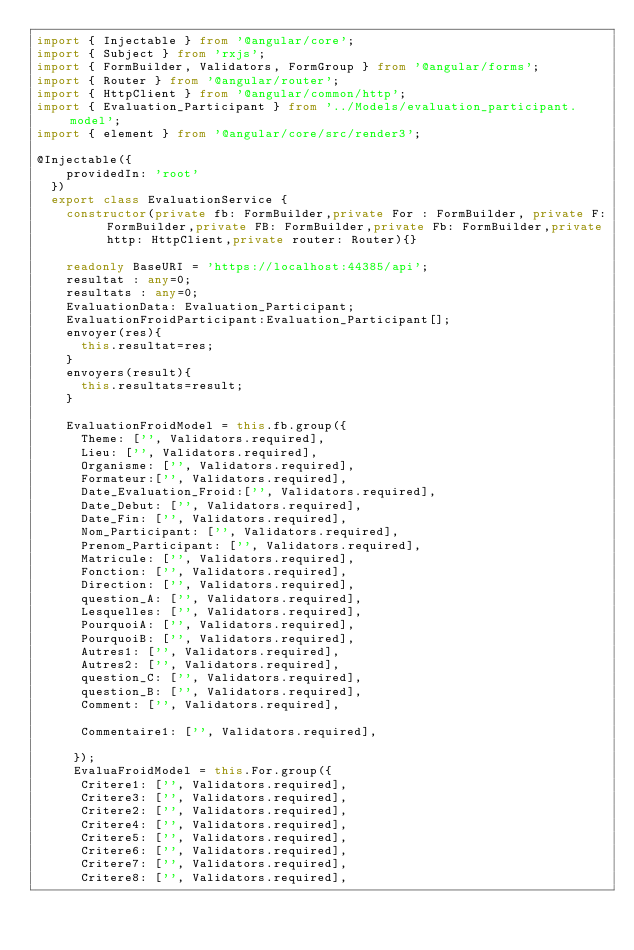Convert code to text. <code><loc_0><loc_0><loc_500><loc_500><_TypeScript_>import { Injectable } from '@angular/core';
import { Subject } from 'rxjs';
import { FormBuilder, Validators, FormGroup } from '@angular/forms';
import { Router } from '@angular/router';
import { HttpClient } from '@angular/common/http';
import { Evaluation_Participant } from '../Models/evaluation_participant.model';
import { element } from '@angular/core/src/render3';

@Injectable({
    providedIn: 'root'
  })
  export class EvaluationService {
    constructor(private fb: FormBuilder,private For : FormBuilder, private F: FormBuilder,private FB: FormBuilder,private Fb: FormBuilder,private http: HttpClient,private router: Router){}

    readonly BaseURI = 'https://localhost:44385/api';
    resultat : any=0;
    resultats : any=0;
    EvaluationData: Evaluation_Participant;
    EvaluationFroidParticipant:Evaluation_Participant[];
    envoyer(res){
      this.resultat=res;
    }
    envoyers(result){
      this.resultats=result;
    }
    
    EvaluationFroidModel = this.fb.group({
      Theme: ['', Validators.required],
      Lieu: ['', Validators.required],
      Organisme: ['', Validators.required],
      Formateur:['', Validators.required],
      Date_Evaluation_Froid:['', Validators.required],
      Date_Debut: ['', Validators.required],
      Date_Fin: ['', Validators.required],
      Nom_Participant: ['', Validators.required],
      Prenom_Participant: ['', Validators.required],
      Matricule: ['', Validators.required],
      Fonction: ['', Validators.required],
      Direction: ['', Validators.required],
      question_A: ['', Validators.required],
      Lesquelles: ['', Validators.required],
      PourquoiA: ['', Validators.required],
      PourquoiB: ['', Validators.required],
      Autres1: ['', Validators.required],
      Autres2: ['', Validators.required],
      question_C: ['', Validators.required],
      question_B: ['', Validators.required],
      Comment: ['', Validators.required],
     
      Commentaire1: ['', Validators.required],
   
     });
     EvaluaFroidModel = this.For.group({
      Critere1: ['', Validators.required],
      Critere3: ['', Validators.required],
      Critere2: ['', Validators.required],
      Critere4: ['', Validators.required],
      Critere5: ['', Validators.required],
      Critere6: ['', Validators.required],
      Critere7: ['', Validators.required],
      Critere8: ['', Validators.required],</code> 